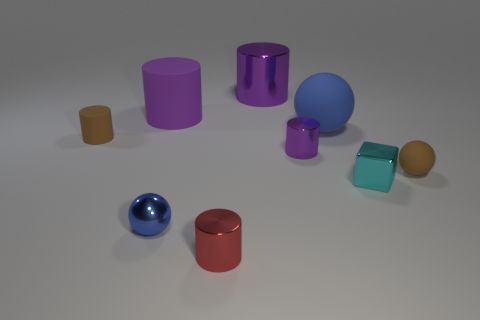Subtract all small spheres. How many spheres are left? 1 Subtract all brown spheres. How many purple cylinders are left? 3 Subtract all brown spheres. How many spheres are left? 2 Subtract all cyan cylinders. Subtract all blue spheres. How many cylinders are left? 5 Subtract all green cylinders. Subtract all big rubber spheres. How many objects are left? 8 Add 8 tiny matte cylinders. How many tiny matte cylinders are left? 9 Add 1 cyan balls. How many cyan balls exist? 1 Subtract 0 purple cubes. How many objects are left? 9 Subtract all spheres. How many objects are left? 6 Subtract 1 spheres. How many spheres are left? 2 